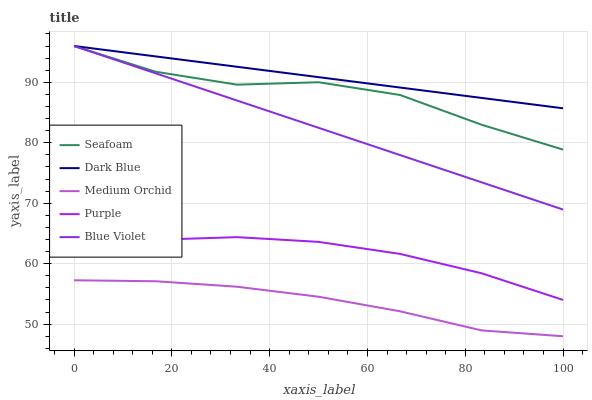Does Medium Orchid have the minimum area under the curve?
Answer yes or no. Yes. Does Dark Blue have the maximum area under the curve?
Answer yes or no. Yes. Does Dark Blue have the minimum area under the curve?
Answer yes or no. No. Does Medium Orchid have the maximum area under the curve?
Answer yes or no. No. Is Blue Violet the smoothest?
Answer yes or no. Yes. Is Seafoam the roughest?
Answer yes or no. Yes. Is Dark Blue the smoothest?
Answer yes or no. No. Is Dark Blue the roughest?
Answer yes or no. No. Does Medium Orchid have the lowest value?
Answer yes or no. Yes. Does Dark Blue have the lowest value?
Answer yes or no. No. Does Blue Violet have the highest value?
Answer yes or no. Yes. Does Medium Orchid have the highest value?
Answer yes or no. No. Is Purple less than Blue Violet?
Answer yes or no. Yes. Is Blue Violet greater than Purple?
Answer yes or no. Yes. Does Dark Blue intersect Blue Violet?
Answer yes or no. Yes. Is Dark Blue less than Blue Violet?
Answer yes or no. No. Is Dark Blue greater than Blue Violet?
Answer yes or no. No. Does Purple intersect Blue Violet?
Answer yes or no. No. 